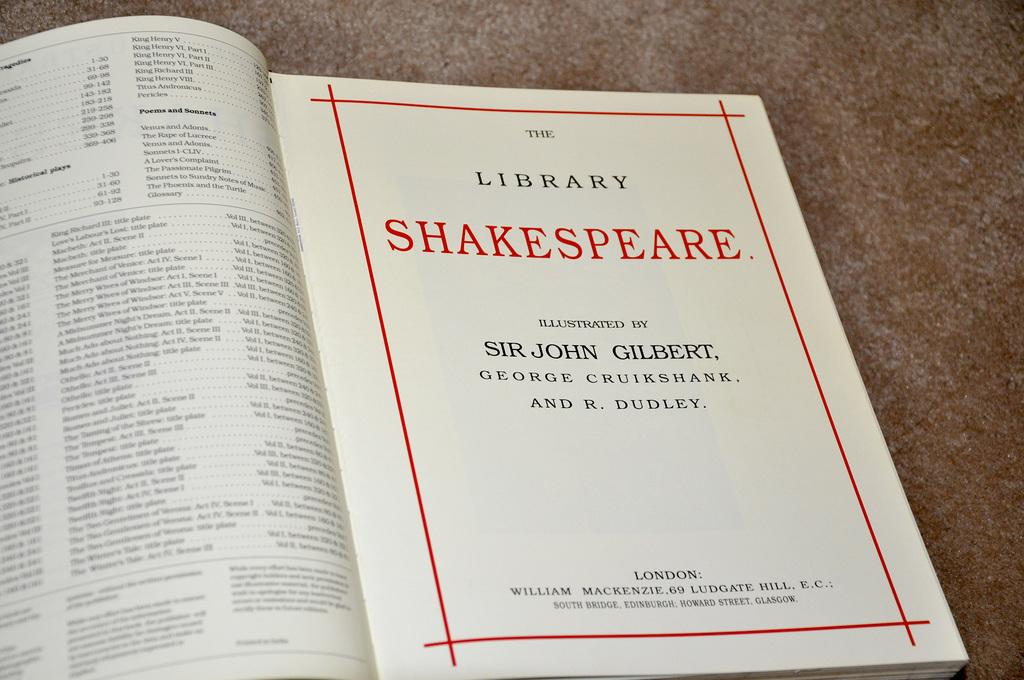Provide a one-sentence caption for the provided image. A book about Shakespeare is open to the title page. 